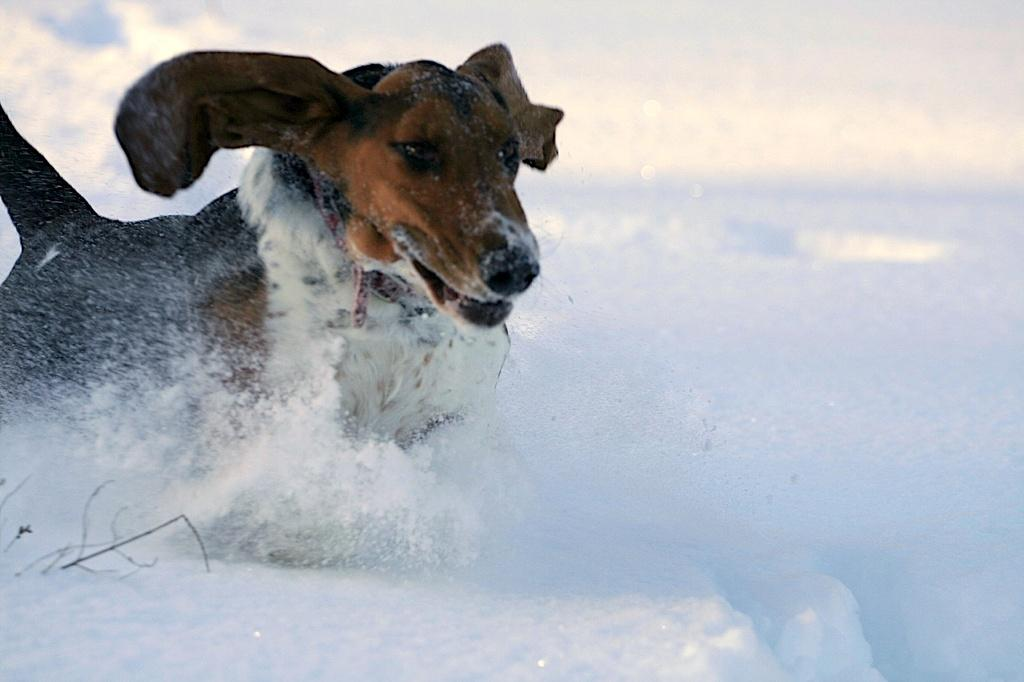What type of animal is present in the image? There is a dog in the image. What is the dog doing in the image? The dog is running. What is the ground made of in the image? There is snow at the bottom of the image. Where is the plant located in the image? There is a plant on the left side of the image. What type of hair is visible on the dog's body in the image? The image does not show the dog's hair, so it cannot be determined from the image. 